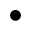Convert formula to latex. <formula><loc_0><loc_0><loc_500><loc_500>\bullet</formula> 